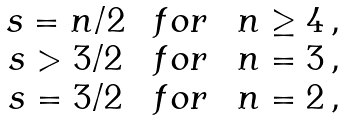Convert formula to latex. <formula><loc_0><loc_0><loc_500><loc_500>\begin{array} { c c l } s = n / 2 & \ f o r \ & n \geq 4 \, , \\ s > 3 / 2 & \ f o r \ & n = 3 \, , \\ s = 3 / 2 & \ f o r \ & n = 2 \, , \end{array}</formula> 